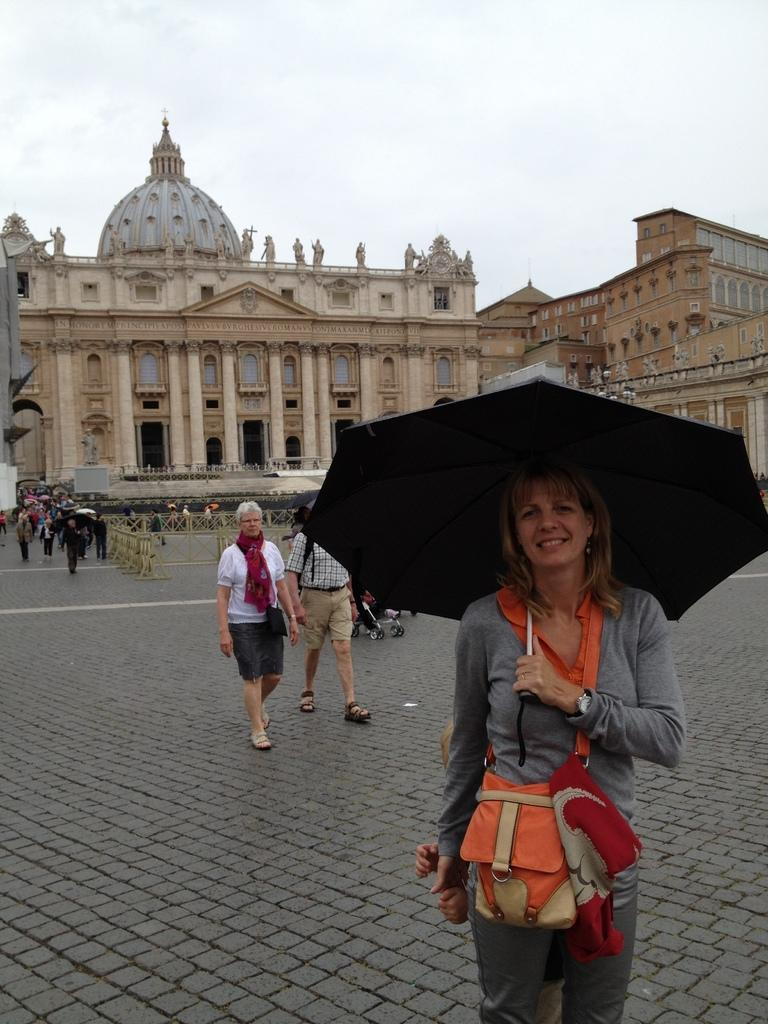What are the people in the image doing? Some of the people are walking in the image. Can you describe the woman in the image? The woman is holding an umbrella. What can be seen in the background of the image? There is a building, an iron railing, and the sky visible in the background of the image. What type of canvas is being used by the people to fight in the image? There is no canvas or fighting present in the image; it features people walking and a woman holding an umbrella. What is the floor made of in the image? The facts provided do not specify the material of the floor in the image. 